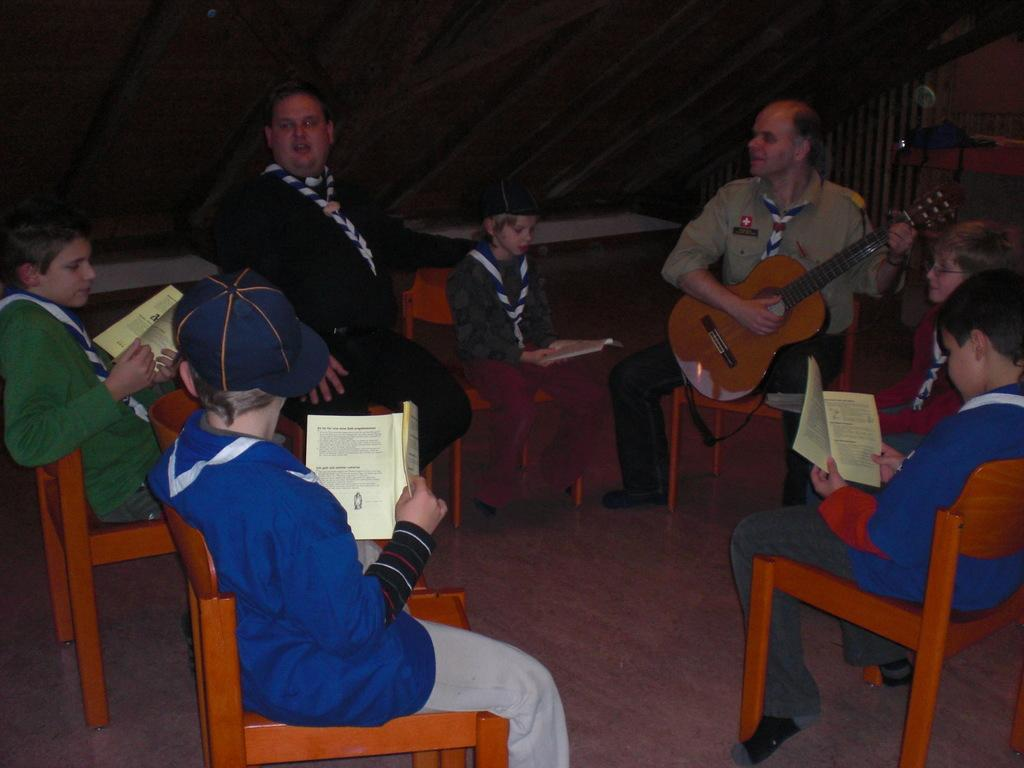What are the people in the image doing? The people in the image are sitting on chairs. Can you describe the man sitting on the right side of the image? The man sitting on the right side of the image is holding a yellow-colored music instrument. What type of dirt can be seen on the floor in the image? There is no dirt visible on the floor in the image. Can you describe the ocean in the image? There is no ocean present in the image. 